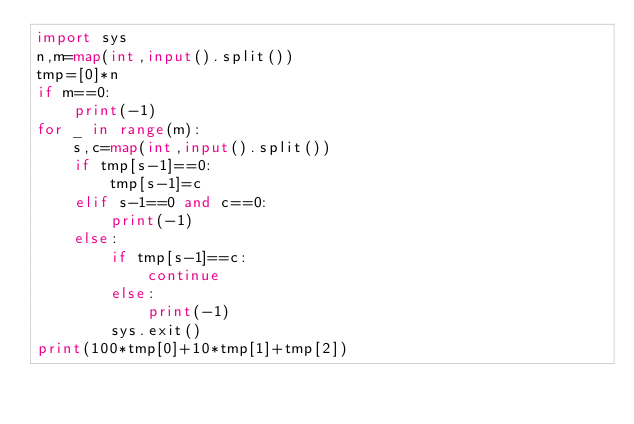<code> <loc_0><loc_0><loc_500><loc_500><_Python_>import sys
n,m=map(int,input().split())
tmp=[0]*n
if m==0:
    print(-1)
for _ in range(m):
    s,c=map(int,input().split())
    if tmp[s-1]==0:
        tmp[s-1]=c
    elif s-1==0 and c==0:
        print(-1)
    else:
        if tmp[s-1]==c:
            continue
        else:
            print(-1)
        sys.exit()
print(100*tmp[0]+10*tmp[1]+tmp[2])</code> 